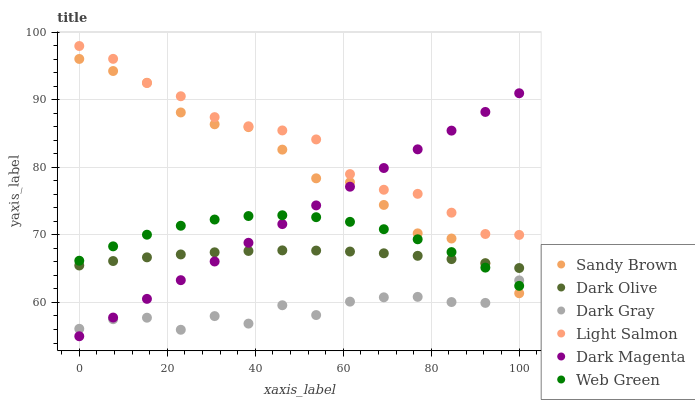Does Dark Gray have the minimum area under the curve?
Answer yes or no. Yes. Does Light Salmon have the maximum area under the curve?
Answer yes or no. Yes. Does Dark Magenta have the minimum area under the curve?
Answer yes or no. No. Does Dark Magenta have the maximum area under the curve?
Answer yes or no. No. Is Dark Magenta the smoothest?
Answer yes or no. Yes. Is Dark Gray the roughest?
Answer yes or no. Yes. Is Dark Olive the smoothest?
Answer yes or no. No. Is Dark Olive the roughest?
Answer yes or no. No. Does Dark Magenta have the lowest value?
Answer yes or no. Yes. Does Dark Olive have the lowest value?
Answer yes or no. No. Does Light Salmon have the highest value?
Answer yes or no. Yes. Does Dark Magenta have the highest value?
Answer yes or no. No. Is Web Green less than Light Salmon?
Answer yes or no. Yes. Is Dark Olive greater than Dark Gray?
Answer yes or no. Yes. Does Dark Magenta intersect Sandy Brown?
Answer yes or no. Yes. Is Dark Magenta less than Sandy Brown?
Answer yes or no. No. Is Dark Magenta greater than Sandy Brown?
Answer yes or no. No. Does Web Green intersect Light Salmon?
Answer yes or no. No. 